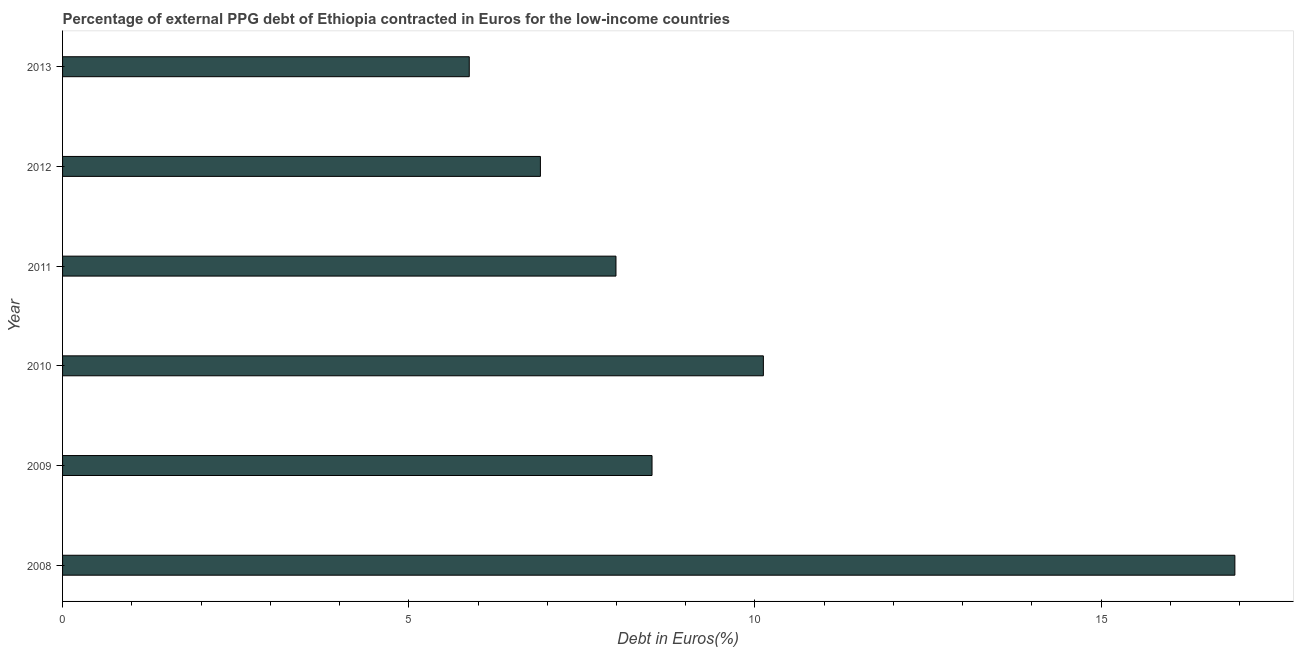Does the graph contain grids?
Your answer should be compact. No. What is the title of the graph?
Your answer should be very brief. Percentage of external PPG debt of Ethiopia contracted in Euros for the low-income countries. What is the label or title of the X-axis?
Keep it short and to the point. Debt in Euros(%). What is the label or title of the Y-axis?
Offer a terse response. Year. What is the currency composition of ppg debt in 2012?
Give a very brief answer. 6.9. Across all years, what is the maximum currency composition of ppg debt?
Provide a succinct answer. 16.93. Across all years, what is the minimum currency composition of ppg debt?
Offer a terse response. 5.87. What is the sum of the currency composition of ppg debt?
Your answer should be compact. 56.33. What is the difference between the currency composition of ppg debt in 2009 and 2010?
Offer a very short reply. -1.61. What is the average currency composition of ppg debt per year?
Your answer should be very brief. 9.39. What is the median currency composition of ppg debt?
Your answer should be very brief. 8.25. Do a majority of the years between 2009 and 2013 (inclusive) have currency composition of ppg debt greater than 1 %?
Ensure brevity in your answer.  Yes. What is the ratio of the currency composition of ppg debt in 2009 to that in 2013?
Your response must be concise. 1.45. Is the currency composition of ppg debt in 2012 less than that in 2013?
Offer a very short reply. No. What is the difference between the highest and the second highest currency composition of ppg debt?
Give a very brief answer. 6.81. What is the difference between the highest and the lowest currency composition of ppg debt?
Offer a very short reply. 11.06. Are all the bars in the graph horizontal?
Your answer should be compact. Yes. How many years are there in the graph?
Your answer should be compact. 6. What is the difference between two consecutive major ticks on the X-axis?
Make the answer very short. 5. What is the Debt in Euros(%) of 2008?
Offer a very short reply. 16.93. What is the Debt in Euros(%) in 2009?
Offer a terse response. 8.51. What is the Debt in Euros(%) in 2010?
Your answer should be very brief. 10.12. What is the Debt in Euros(%) in 2011?
Your response must be concise. 7.99. What is the Debt in Euros(%) in 2012?
Your answer should be compact. 6.9. What is the Debt in Euros(%) of 2013?
Give a very brief answer. 5.87. What is the difference between the Debt in Euros(%) in 2008 and 2009?
Keep it short and to the point. 8.42. What is the difference between the Debt in Euros(%) in 2008 and 2010?
Your answer should be compact. 6.81. What is the difference between the Debt in Euros(%) in 2008 and 2011?
Your answer should be very brief. 8.94. What is the difference between the Debt in Euros(%) in 2008 and 2012?
Ensure brevity in your answer.  10.03. What is the difference between the Debt in Euros(%) in 2008 and 2013?
Ensure brevity in your answer.  11.06. What is the difference between the Debt in Euros(%) in 2009 and 2010?
Your answer should be very brief. -1.61. What is the difference between the Debt in Euros(%) in 2009 and 2011?
Your answer should be compact. 0.52. What is the difference between the Debt in Euros(%) in 2009 and 2012?
Offer a very short reply. 1.61. What is the difference between the Debt in Euros(%) in 2009 and 2013?
Offer a terse response. 2.64. What is the difference between the Debt in Euros(%) in 2010 and 2011?
Your answer should be very brief. 2.13. What is the difference between the Debt in Euros(%) in 2010 and 2012?
Provide a short and direct response. 3.22. What is the difference between the Debt in Euros(%) in 2010 and 2013?
Ensure brevity in your answer.  4.25. What is the difference between the Debt in Euros(%) in 2011 and 2012?
Your response must be concise. 1.09. What is the difference between the Debt in Euros(%) in 2011 and 2013?
Ensure brevity in your answer.  2.12. What is the difference between the Debt in Euros(%) in 2012 and 2013?
Keep it short and to the point. 1.03. What is the ratio of the Debt in Euros(%) in 2008 to that in 2009?
Ensure brevity in your answer.  1.99. What is the ratio of the Debt in Euros(%) in 2008 to that in 2010?
Your response must be concise. 1.67. What is the ratio of the Debt in Euros(%) in 2008 to that in 2011?
Ensure brevity in your answer.  2.12. What is the ratio of the Debt in Euros(%) in 2008 to that in 2012?
Your answer should be very brief. 2.45. What is the ratio of the Debt in Euros(%) in 2008 to that in 2013?
Offer a very short reply. 2.88. What is the ratio of the Debt in Euros(%) in 2009 to that in 2010?
Offer a terse response. 0.84. What is the ratio of the Debt in Euros(%) in 2009 to that in 2011?
Offer a very short reply. 1.06. What is the ratio of the Debt in Euros(%) in 2009 to that in 2012?
Keep it short and to the point. 1.23. What is the ratio of the Debt in Euros(%) in 2009 to that in 2013?
Your response must be concise. 1.45. What is the ratio of the Debt in Euros(%) in 2010 to that in 2011?
Give a very brief answer. 1.27. What is the ratio of the Debt in Euros(%) in 2010 to that in 2012?
Your answer should be very brief. 1.47. What is the ratio of the Debt in Euros(%) in 2010 to that in 2013?
Ensure brevity in your answer.  1.72. What is the ratio of the Debt in Euros(%) in 2011 to that in 2012?
Your response must be concise. 1.16. What is the ratio of the Debt in Euros(%) in 2011 to that in 2013?
Provide a succinct answer. 1.36. What is the ratio of the Debt in Euros(%) in 2012 to that in 2013?
Your answer should be very brief. 1.18. 